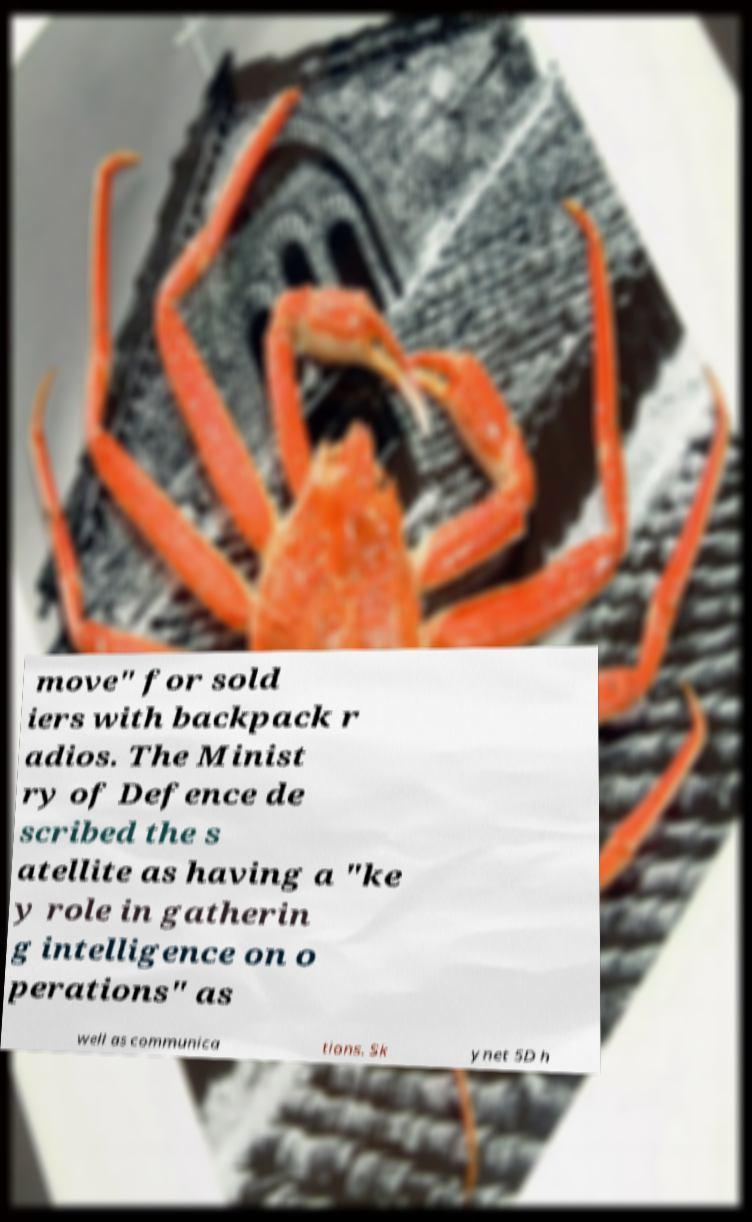What messages or text are displayed in this image? I need them in a readable, typed format. move" for sold iers with backpack r adios. The Minist ry of Defence de scribed the s atellite as having a "ke y role in gatherin g intelligence on o perations" as well as communica tions. Sk ynet 5D h 